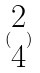<formula> <loc_0><loc_0><loc_500><loc_500>( \begin{matrix} 2 \\ 4 \end{matrix} )</formula> 